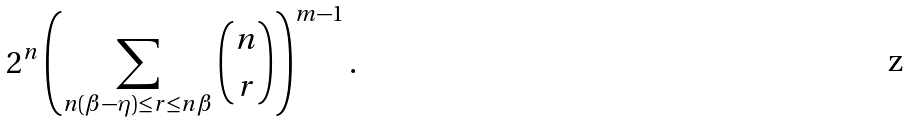Convert formula to latex. <formula><loc_0><loc_0><loc_500><loc_500>2 ^ { n } \left ( \sum _ { n ( \beta - \eta ) \leq r \leq n \beta } { n \choose r } \right ) ^ { m - 1 } .</formula> 